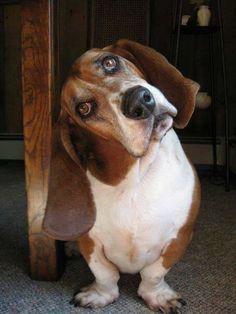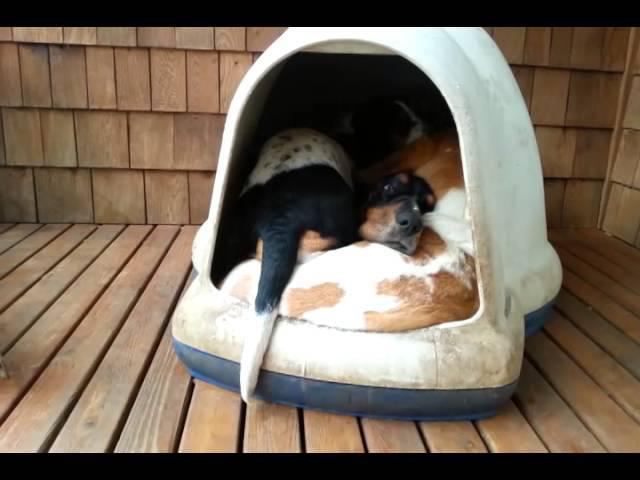The first image is the image on the left, the second image is the image on the right. Assess this claim about the two images: "There is at least two dogs in the right image.". Correct or not? Answer yes or no. Yes. The first image is the image on the left, the second image is the image on the right. Evaluate the accuracy of this statement regarding the images: "At least one of the dogs is lying down with its belly on the floor.". Is it true? Answer yes or no. No. 